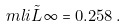<formula> <loc_0><loc_0><loc_500><loc_500>\ m l i { \tilde { L } } { \infty } = 0 . 2 5 8 \, .</formula> 